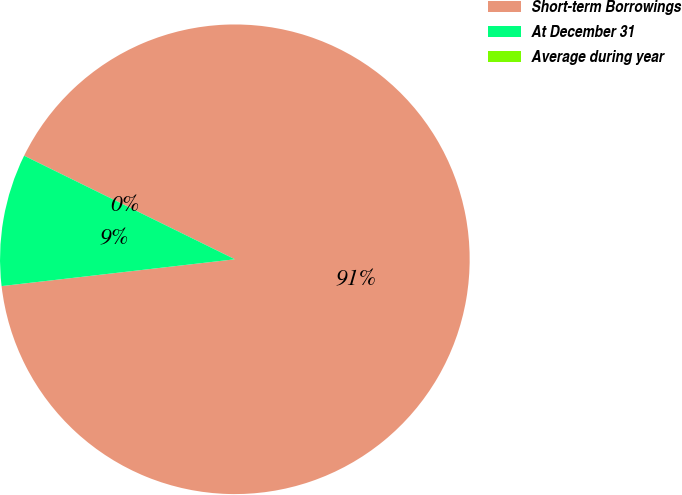<chart> <loc_0><loc_0><loc_500><loc_500><pie_chart><fcel>Short-term Borrowings<fcel>At December 31<fcel>Average during year<nl><fcel>90.9%<fcel>9.09%<fcel>0.0%<nl></chart> 